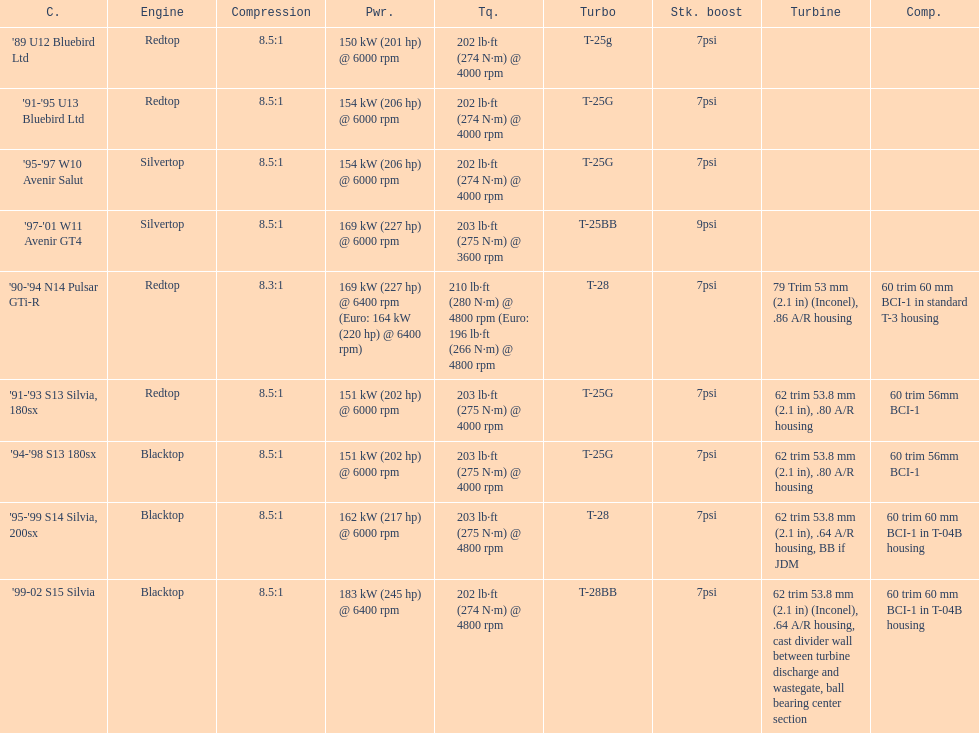Which engines are the same as the first entry ('89 u12 bluebird ltd)? '91-'95 U13 Bluebird Ltd, '90-'94 N14 Pulsar GTi-R, '91-'93 S13 Silvia, 180sx. 